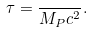Convert formula to latex. <formula><loc_0><loc_0><loc_500><loc_500>\tau = \frac { } { M _ { P } c ^ { 2 } } .</formula> 